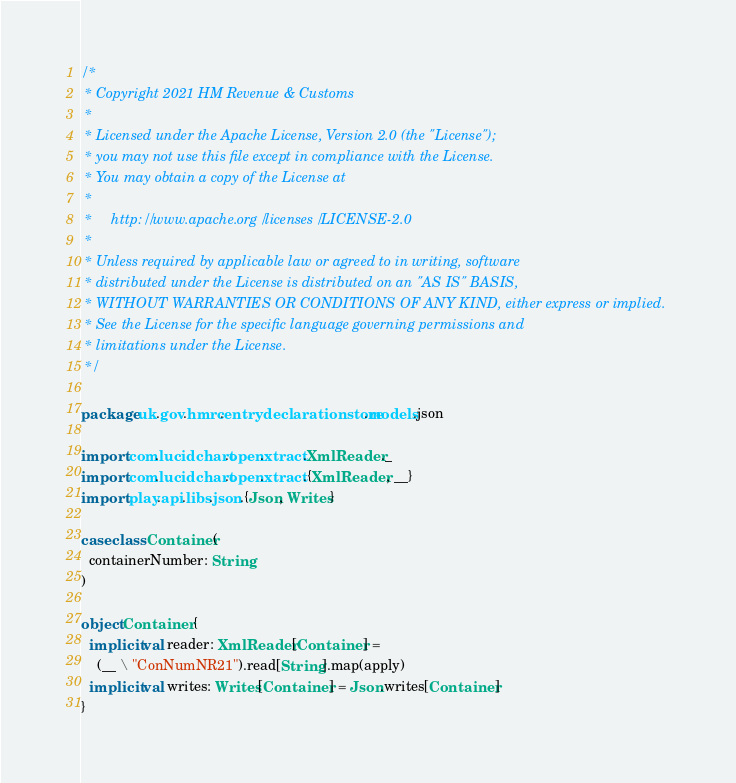Convert code to text. <code><loc_0><loc_0><loc_500><loc_500><_Scala_>/*
 * Copyright 2021 HM Revenue & Customs
 *
 * Licensed under the Apache License, Version 2.0 (the "License");
 * you may not use this file except in compliance with the License.
 * You may obtain a copy of the License at
 *
 *     http://www.apache.org/licenses/LICENSE-2.0
 *
 * Unless required by applicable law or agreed to in writing, software
 * distributed under the License is distributed on an "AS IS" BASIS,
 * WITHOUT WARRANTIES OR CONDITIONS OF ANY KIND, either express or implied.
 * See the License for the specific language governing permissions and
 * limitations under the License.
 */

package uk.gov.hmrc.entrydeclarationstore.models.json

import com.lucidchart.open.xtract.XmlReader._
import com.lucidchart.open.xtract.{XmlReader, __}
import play.api.libs.json.{Json, Writes}

case class Container(
  containerNumber: String
)

object Container {
  implicit val reader: XmlReader[Container] =
    (__ \ "ConNumNR21").read[String].map(apply)
  implicit val writes: Writes[Container] = Json.writes[Container]
}
</code> 